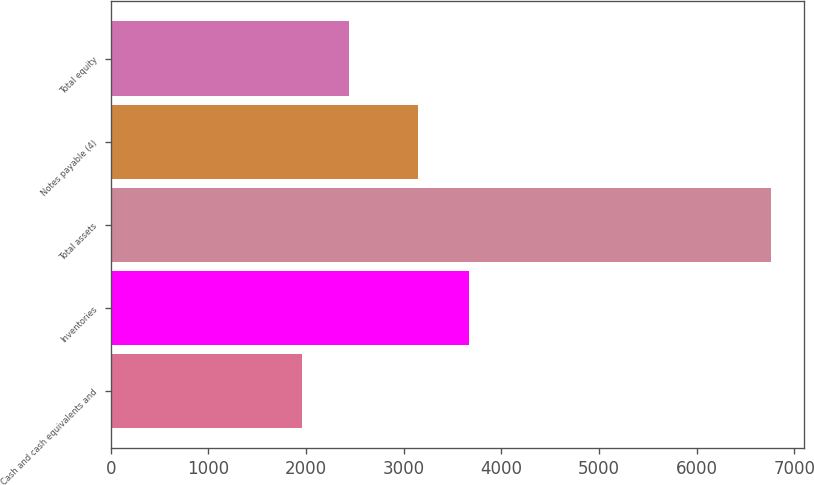Convert chart to OTSL. <chart><loc_0><loc_0><loc_500><loc_500><bar_chart><fcel>Cash and cash equivalents and<fcel>Inventories<fcel>Total assets<fcel>Notes payable (4)<fcel>Total equity<nl><fcel>1957.3<fcel>3666.7<fcel>6756.8<fcel>3145.3<fcel>2437.25<nl></chart> 